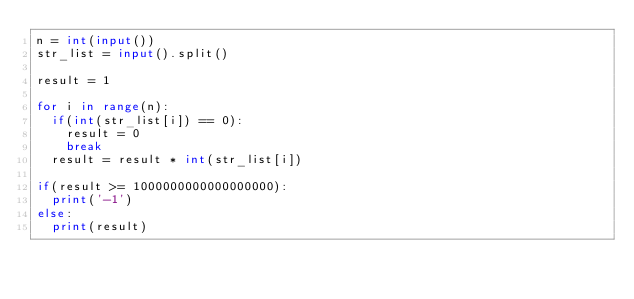Convert code to text. <code><loc_0><loc_0><loc_500><loc_500><_Python_>n = int(input())
str_list = input().split()

result = 1

for i in range(n):
  if(int(str_list[i]) == 0):
    result = 0
    break
  result = result * int(str_list[i])

if(result >= 1000000000000000000):
  print('-1')
else:
  print(result)
   
</code> 